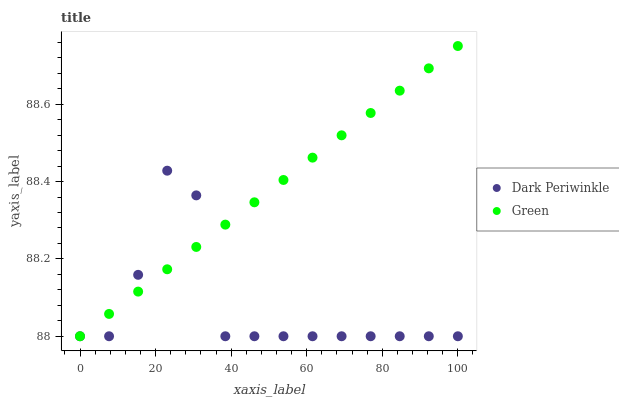Does Dark Periwinkle have the minimum area under the curve?
Answer yes or no. Yes. Does Green have the maximum area under the curve?
Answer yes or no. Yes. Does Dark Periwinkle have the maximum area under the curve?
Answer yes or no. No. Is Green the smoothest?
Answer yes or no. Yes. Is Dark Periwinkle the roughest?
Answer yes or no. Yes. Is Dark Periwinkle the smoothest?
Answer yes or no. No. Does Green have the lowest value?
Answer yes or no. Yes. Does Green have the highest value?
Answer yes or no. Yes. Does Dark Periwinkle have the highest value?
Answer yes or no. No. Does Green intersect Dark Periwinkle?
Answer yes or no. Yes. Is Green less than Dark Periwinkle?
Answer yes or no. No. Is Green greater than Dark Periwinkle?
Answer yes or no. No. 